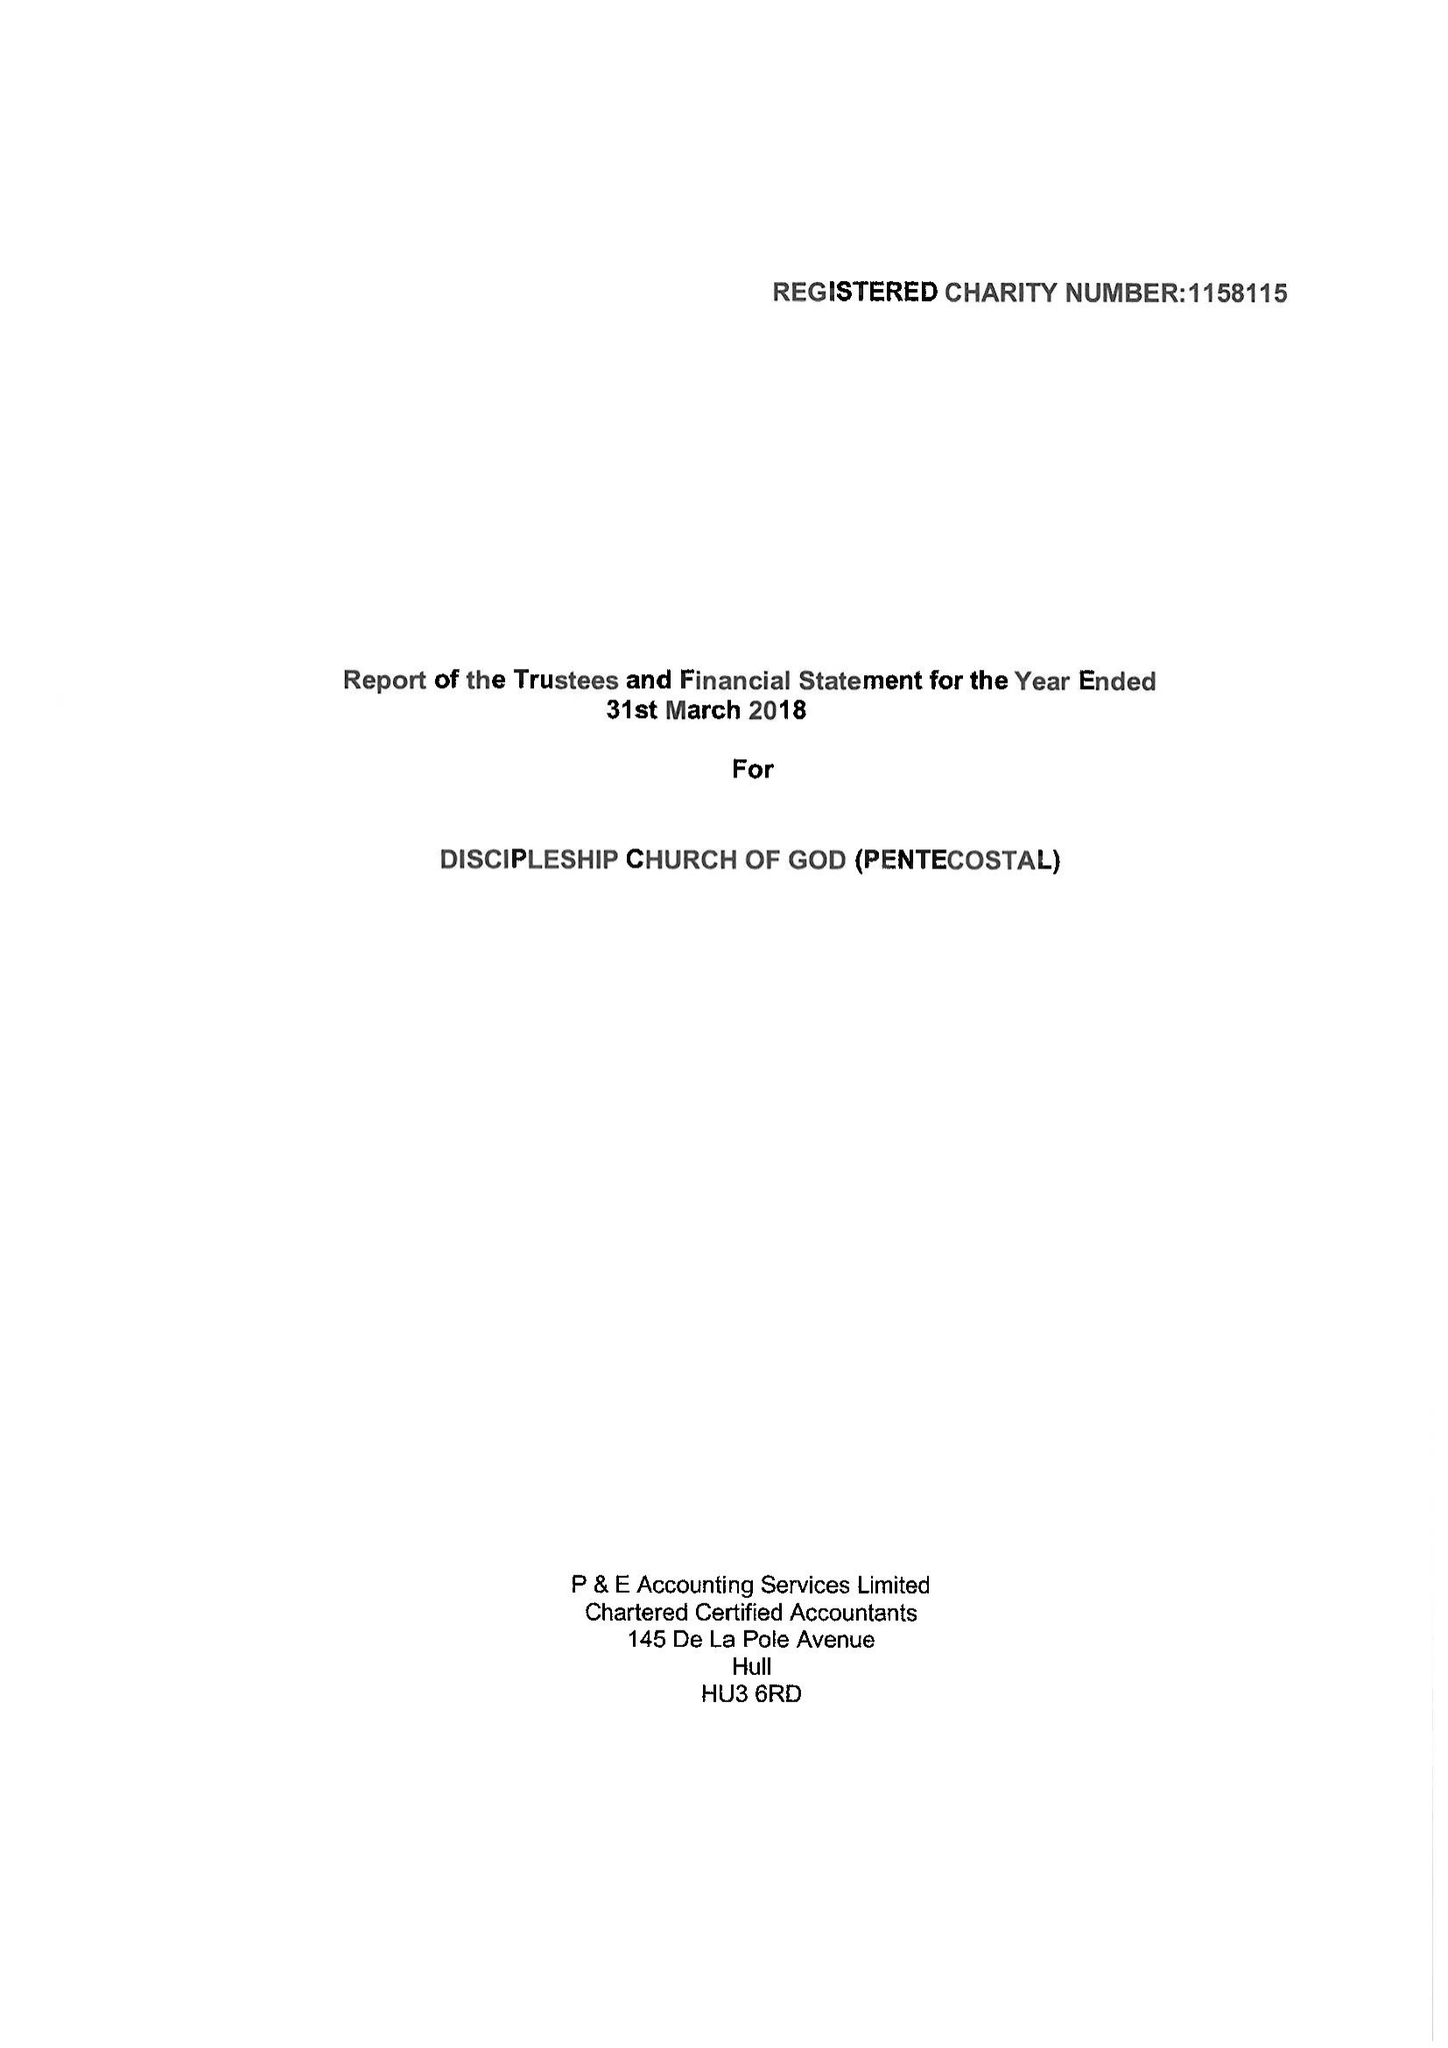What is the value for the charity_number?
Answer the question using a single word or phrase. 1158115 